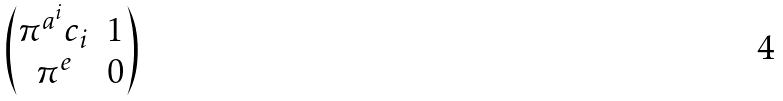<formula> <loc_0><loc_0><loc_500><loc_500>\begin{pmatrix} \pi ^ { a ^ { i } } c _ { i } & 1 \\ \pi ^ { e } & 0 \end{pmatrix}</formula> 